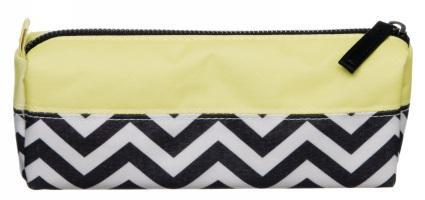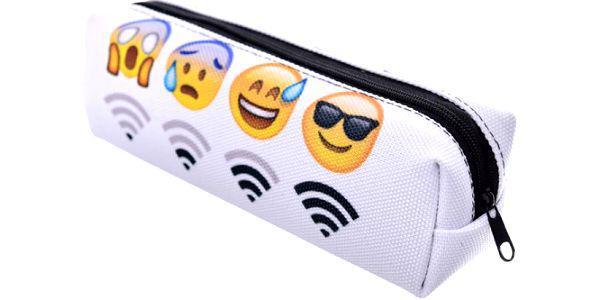The first image is the image on the left, the second image is the image on the right. Considering the images on both sides, is "A zipper case has a black-and-white zig zag pattern on the bottom and a yellowish band across the top." valid? Answer yes or no. Yes. 